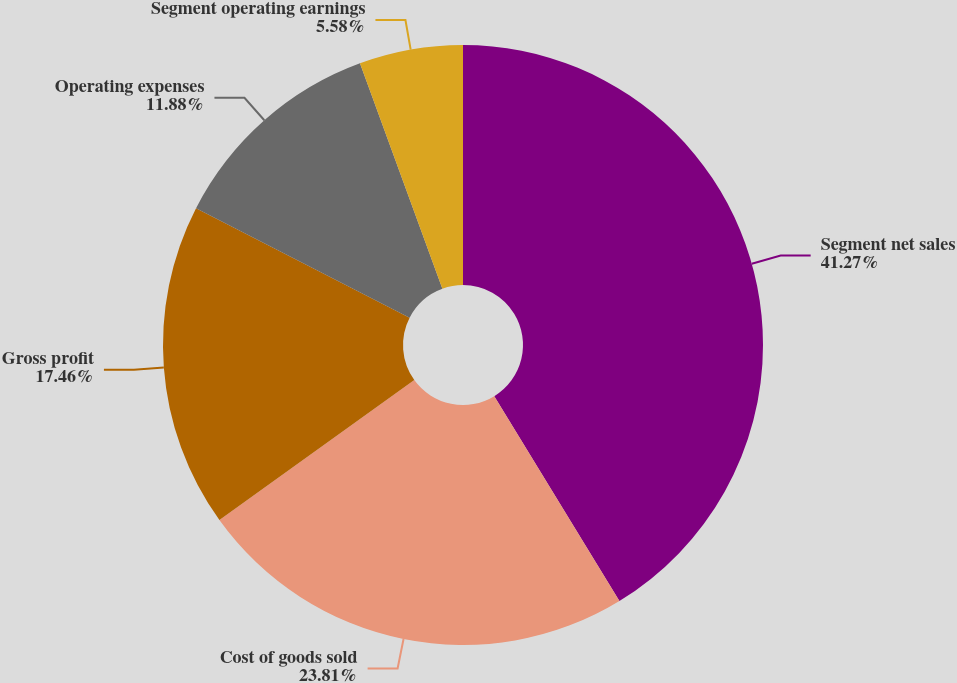Convert chart. <chart><loc_0><loc_0><loc_500><loc_500><pie_chart><fcel>Segment net sales<fcel>Cost of goods sold<fcel>Gross profit<fcel>Operating expenses<fcel>Segment operating earnings<nl><fcel>41.27%<fcel>23.81%<fcel>17.46%<fcel>11.88%<fcel>5.58%<nl></chart> 